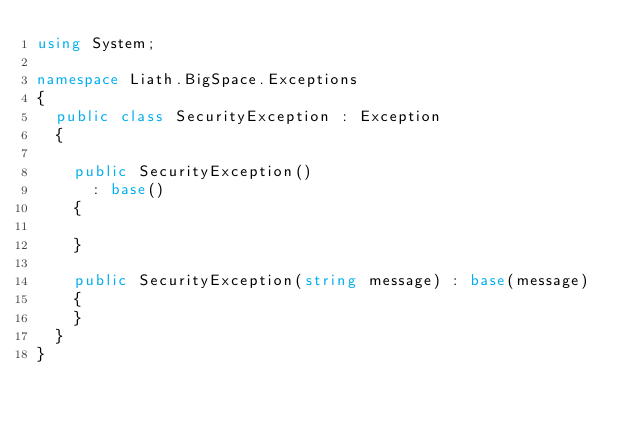Convert code to text. <code><loc_0><loc_0><loc_500><loc_500><_C#_>using System;

namespace Liath.BigSpace.Exceptions
{
	public class SecurityException : Exception
	{

		public SecurityException()
			: base()
		{
			
		}

		public SecurityException(string message) : base(message)
		{
		}
	}
}</code> 